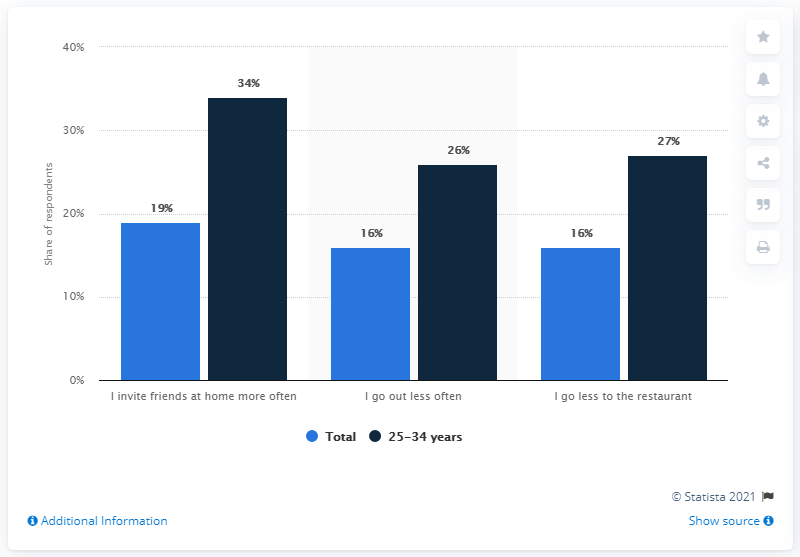Give some essential details in this illustration. Among all respondents, the percentage was found to be 16%. 